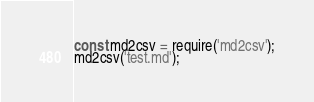Convert code to text. <code><loc_0><loc_0><loc_500><loc_500><_JavaScript_>const md2csv = require('md2csv');
md2csv('test.md');</code> 